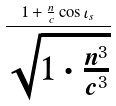Convert formula to latex. <formula><loc_0><loc_0><loc_500><loc_500>\frac { 1 + \frac { n } { c } \cos \iota _ { s } } { \sqrt { 1 \cdot \frac { n ^ { 3 } } { c ^ { 3 } } } }</formula> 